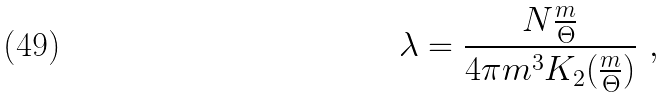<formula> <loc_0><loc_0><loc_500><loc_500>\lambda = \frac { N \frac { m } { \Theta } } { 4 \pi m ^ { 3 } K _ { 2 } ( \frac { m } { \Theta } ) } \ ,</formula> 